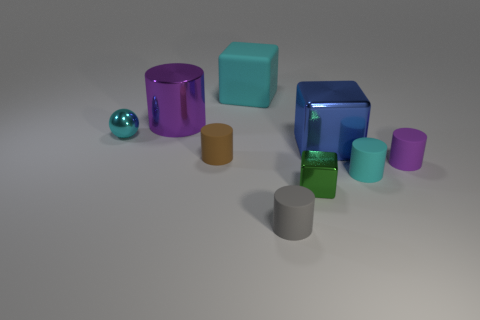How do the shadows cast by the objects inform us about the light source in the scene? The shadows cast by the objects are soft and extend mostly to the right of each object, indicating that the light source is positioned to the top-left of the scene. The length and angle of the shadows can also help us infer the distance and size of the light source. Are the shadows all consistent with each other? Yes, all the shadows in the scene are consistent with one another. They all fall in the same direction and have a similar softness, confirming that the objects are illuminated by a single light source. 